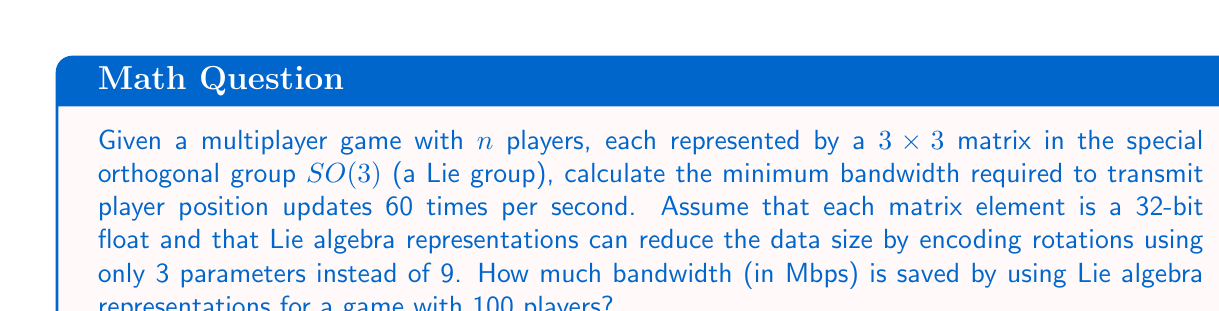Teach me how to tackle this problem. Let's approach this step-by-step:

1) First, let's calculate the bandwidth without using Lie algebra representations:
   - Each player is represented by a $3\times 3$ matrix = 9 elements
   - Each element is a 32-bit float = 4 bytes
   - Total bytes per player = $9 \times 4 = 36$ bytes
   - For 100 players: $100 \times 36 = 3600$ bytes per update
   - At 60 updates per second: $3600 \times 60 = 216000$ bytes/second
   - Convert to Mbps: $216000 \times 8 \div 1000000 = 1.728$ Mbps

2) Now, let's calculate using Lie algebra representations:
   - Each player rotation can be represented by 3 parameters
   - Each parameter is still a 32-bit float = 4 bytes
   - Total bytes per player = $3 \times 4 = 12$ bytes
   - For 100 players: $100 \times 12 = 1200$ bytes per update
   - At 60 updates per second: $1200 \times 60 = 72000$ bytes/second
   - Convert to Mbps: $72000 \times 8 \div 1000000 = 0.576$ Mbps

3) Calculate the bandwidth saved:
   $1.728 - 0.576 = 1.152$ Mbps

The Lie algebra representation saves 1.152 Mbps of bandwidth.
Answer: 1.152 Mbps 